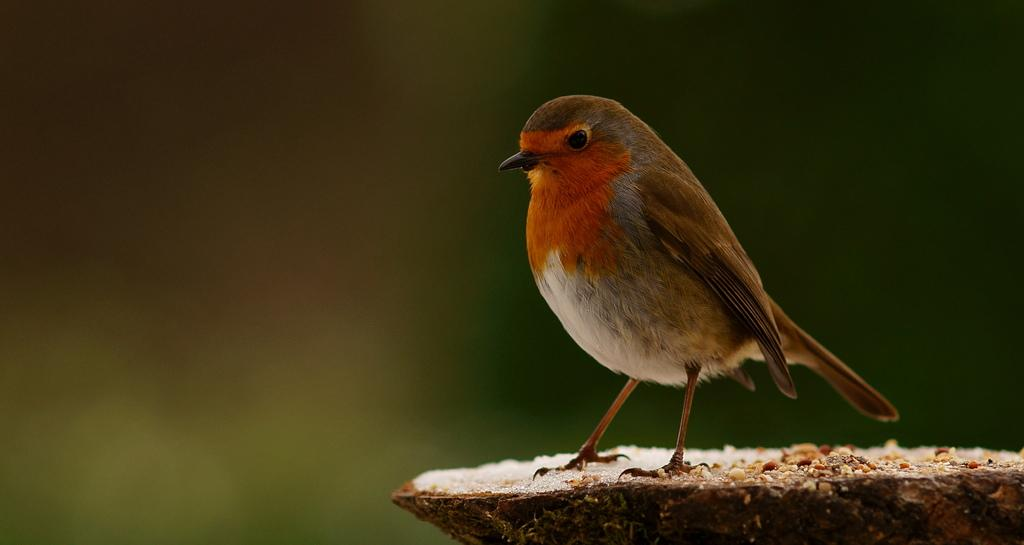What type of animal is present in the image? There is a bird in the image. Where is the bird located? The bird is on a piece of wood. What else can be seen on the wood? There is food on the wood. Can you describe the background of the image? The background of the image is blurry. What type of cushion is the bird using to join the glove in the image? There is no cushion or glove present in the image; it features a bird on a piece of wood with food. 